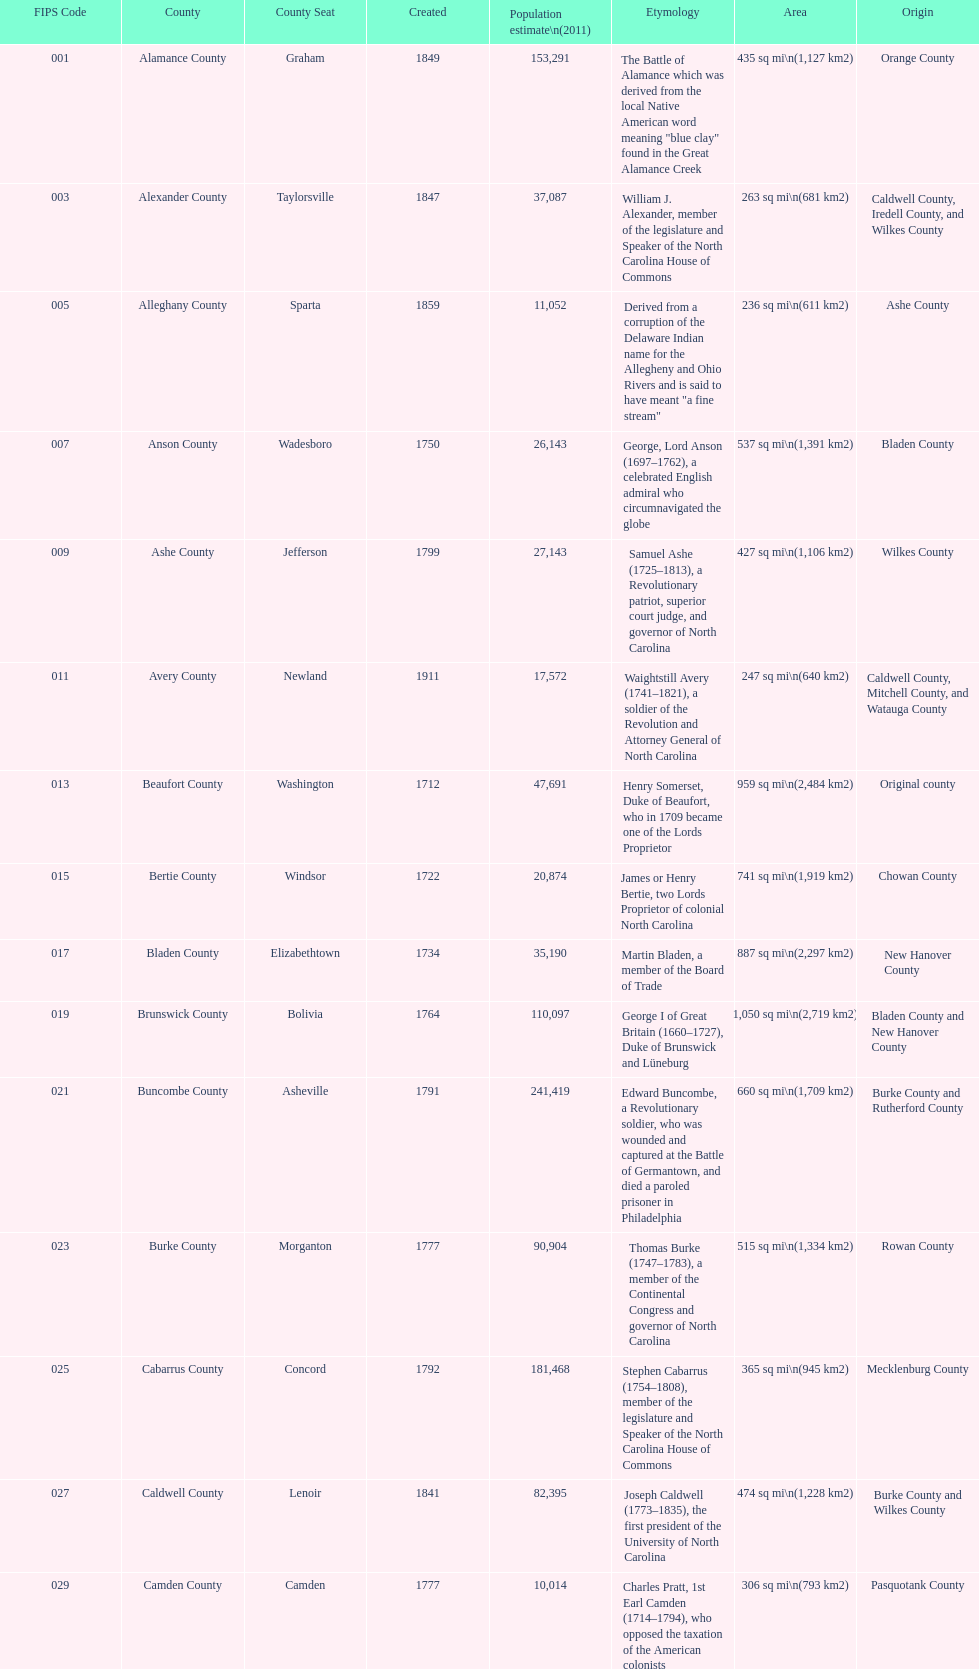Which county has a higher population, alamance or alexander? Alamance County. 